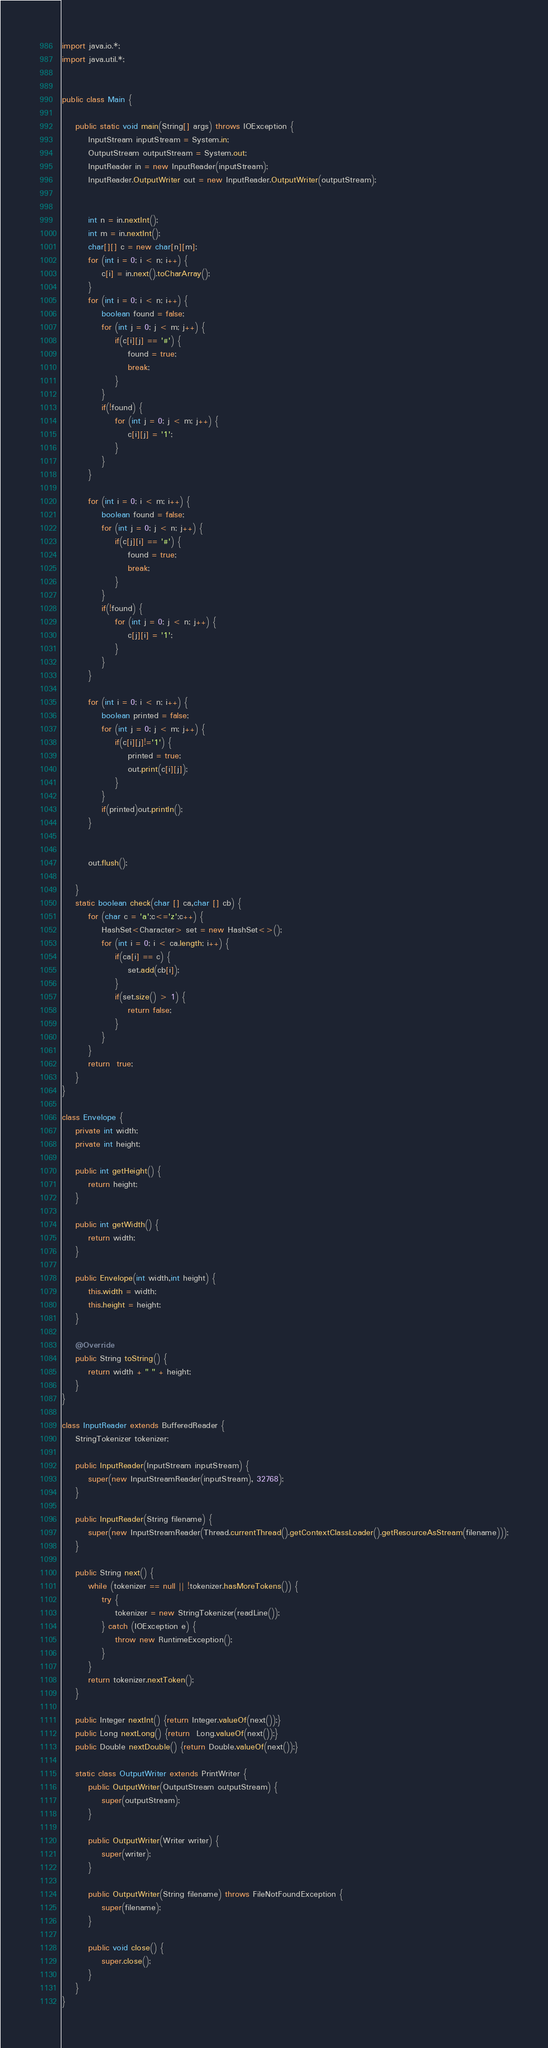Convert code to text. <code><loc_0><loc_0><loc_500><loc_500><_Java_>import java.io.*;
import java.util.*;


public class Main {

    public static void main(String[] args) throws IOException {
        InputStream inputStream = System.in;
        OutputStream outputStream = System.out;
        InputReader in = new InputReader(inputStream);
        InputReader.OutputWriter out = new InputReader.OutputWriter(outputStream);


        int n = in.nextInt();
        int m = in.nextInt();
        char[][] c = new char[n][m];
        for (int i = 0; i < n; i++) {
            c[i] = in.next().toCharArray();
        }
        for (int i = 0; i < n; i++) {
            boolean found = false;
            for (int j = 0; j < m; j++) {
                if(c[i][j] == '#') {
                    found = true;
                    break;
                }
            }
            if(!found) {
                for (int j = 0; j < m; j++) {
                    c[i][j] = '1';
                }
            }
        }

        for (int i = 0; i < m; i++) {
            boolean found = false;
            for (int j = 0; j < n; j++) {
                if(c[j][i] == '#') {
                    found = true;
                    break;
                }
            }
            if(!found) {
                for (int j = 0; j < n; j++) {
                    c[j][i] = '1';
                }
            }
        }

        for (int i = 0; i < n; i++) {
            boolean printed = false;
            for (int j = 0; j < m; j++) {
                if(c[i][j]!='1') {
                    printed = true;
                    out.print(c[i][j]);
                }
            }
            if(printed)out.println();
        }


        out.flush();

    }
    static boolean check(char [] ca,char [] cb) {
        for (char c = 'a';c<='z';c++) {
            HashSet<Character> set = new HashSet<>();
            for (int i = 0; i < ca.length; i++) {
                if(ca[i] == c) {
                    set.add(cb[i]);
                }
                if(set.size() > 1) {
                    return false;
                }
            }
        }
        return  true;
    }
}

class Envelope {
    private int width;
    private int height;

    public int getHeight() {
        return height;
    }

    public int getWidth() {
        return width;
    }

    public Envelope(int width,int height) {
        this.width = width;
        this.height = height;
    }

    @Override
    public String toString() {
        return width + " " + height;
    }
}

class InputReader extends BufferedReader {
    StringTokenizer tokenizer;

    public InputReader(InputStream inputStream) {
        super(new InputStreamReader(inputStream), 32768);
    }

    public InputReader(String filename) {
        super(new InputStreamReader(Thread.currentThread().getContextClassLoader().getResourceAsStream(filename)));
    }

    public String next() {
        while (tokenizer == null || !tokenizer.hasMoreTokens()) {
            try {
                tokenizer = new StringTokenizer(readLine());
            } catch (IOException e) {
                throw new RuntimeException();
            }
        }
        return tokenizer.nextToken();
    }

    public Integer nextInt() {return Integer.valueOf(next());}
    public Long nextLong() {return  Long.valueOf(next());}
    public Double nextDouble() {return Double.valueOf(next());}

    static class OutputWriter extends PrintWriter {
        public OutputWriter(OutputStream outputStream) {
            super(outputStream);
        }

        public OutputWriter(Writer writer) {
            super(writer);
        }

        public OutputWriter(String filename) throws FileNotFoundException {
            super(filename);
        }

        public void close() {
            super.close();
        }
    }
}</code> 